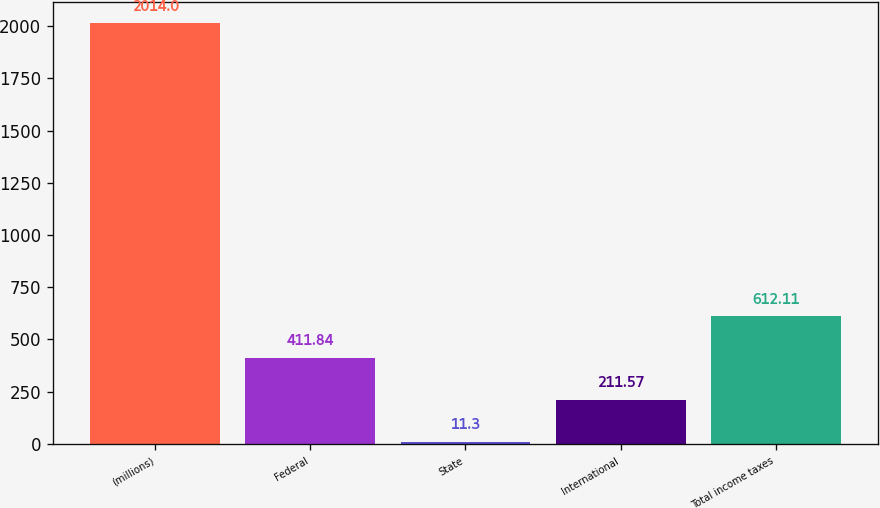Convert chart to OTSL. <chart><loc_0><loc_0><loc_500><loc_500><bar_chart><fcel>(millions)<fcel>Federal<fcel>State<fcel>International<fcel>Total income taxes<nl><fcel>2014<fcel>411.84<fcel>11.3<fcel>211.57<fcel>612.11<nl></chart> 